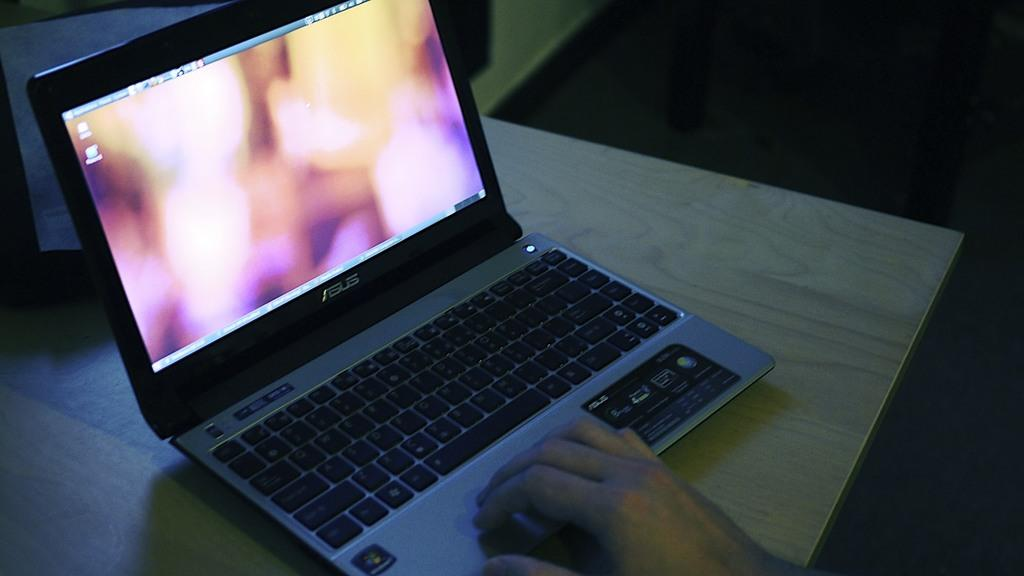What electronic device is visible in the image? There is a laptop in the image. Where is the laptop located? The laptop is placed on a table. Who is interacting with the laptop? A person's hand is using the laptop. What can be observed about the lighting in the image? The background of the image is dark. What type of headwear is the scarecrow wearing in the image? There is no scarecrow present in the image, so it is not possible to determine what type of headwear it might be wearing. 